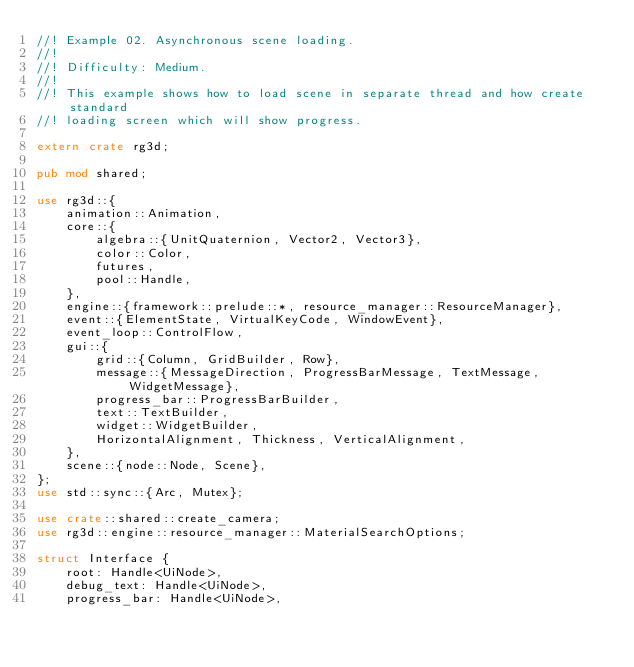Convert code to text. <code><loc_0><loc_0><loc_500><loc_500><_Rust_>//! Example 02. Asynchronous scene loading.
//!
//! Difficulty: Medium.
//!
//! This example shows how to load scene in separate thread and how create standard
//! loading screen which will show progress.

extern crate rg3d;

pub mod shared;

use rg3d::{
    animation::Animation,
    core::{
        algebra::{UnitQuaternion, Vector2, Vector3},
        color::Color,
        futures,
        pool::Handle,
    },
    engine::{framework::prelude::*, resource_manager::ResourceManager},
    event::{ElementState, VirtualKeyCode, WindowEvent},
    event_loop::ControlFlow,
    gui::{
        grid::{Column, GridBuilder, Row},
        message::{MessageDirection, ProgressBarMessage, TextMessage, WidgetMessage},
        progress_bar::ProgressBarBuilder,
        text::TextBuilder,
        widget::WidgetBuilder,
        HorizontalAlignment, Thickness, VerticalAlignment,
    },
    scene::{node::Node, Scene},
};
use std::sync::{Arc, Mutex};

use crate::shared::create_camera;
use rg3d::engine::resource_manager::MaterialSearchOptions;

struct Interface {
    root: Handle<UiNode>,
    debug_text: Handle<UiNode>,
    progress_bar: Handle<UiNode>,</code> 